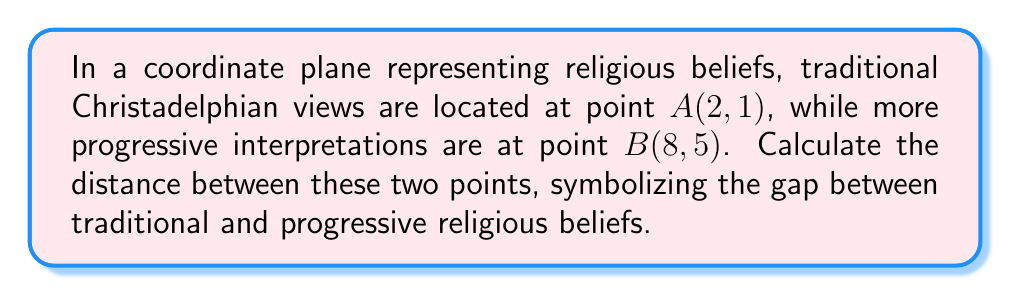Can you answer this question? To find the distance between two points on a coordinate plane, we use the distance formula:

$$ d = \sqrt{(x_2 - x_1)^2 + (y_2 - y_1)^2} $$

Where $(x_1, y_1)$ are the coordinates of the first point and $(x_2, y_2)$ are the coordinates of the second point.

Given:
Point A (traditional views): $(2, 1)$
Point B (progressive views): $(8, 5)$

Step 1: Identify the coordinates
$x_1 = 2$, $y_1 = 1$
$x_2 = 8$, $y_2 = 5$

Step 2: Substitute these values into the distance formula
$$ d = \sqrt{(8 - 2)^2 + (5 - 1)^2} $$

Step 3: Simplify inside the parentheses
$$ d = \sqrt{6^2 + 4^2} $$

Step 4: Calculate the squares
$$ d = \sqrt{36 + 16} $$

Step 5: Add under the square root
$$ d = \sqrt{52} $$

Step 6: Simplify the square root
$$ d = 2\sqrt{13} $$

This distance represents the gap between traditional and progressive Christadelphian beliefs on our symbolic coordinate plane.
Answer: $2\sqrt{13}$ 